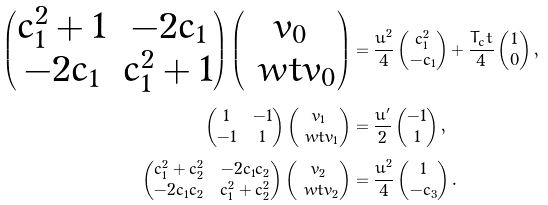<formula> <loc_0><loc_0><loc_500><loc_500>\begin{pmatrix} c _ { 1 } ^ { 2 } + 1 & - 2 c _ { 1 } \\ - 2 c _ { 1 } & c _ { 1 } ^ { 2 } + 1 \end{pmatrix} \begin{pmatrix} v _ { 0 } \\ \ w t { v } _ { 0 } \end{pmatrix} & = \frac { u ^ { 2 } } { 4 } \begin{pmatrix} c _ { 1 } ^ { 2 } \\ - c _ { 1 } \end{pmatrix} + \frac { T _ { c } t } { 4 } \begin{pmatrix} 1 \\ 0 \end{pmatrix} , \\ \begin{pmatrix} 1 & - 1 \\ - 1 & 1 \end{pmatrix} \begin{pmatrix} v _ { 1 } \\ \ w t v _ { 1 } \end{pmatrix} & = \frac { u ^ { \prime } } { 2 } \begin{pmatrix} - 1 \\ 1 \end{pmatrix} , \\ \begin{pmatrix} c _ { 1 } ^ { 2 } + c _ { 2 } ^ { 2 } & - 2 c _ { 1 } c _ { 2 } \\ - 2 c _ { 1 } c _ { 2 } & c _ { 1 } ^ { 2 } + c _ { 2 } ^ { 2 } \end{pmatrix} \begin{pmatrix} v _ { 2 } \\ \ w t v _ { 2 } \end{pmatrix} & = \frac { u ^ { 2 } } { 4 } \begin{pmatrix} 1 \\ - c _ { 3 } \end{pmatrix} .</formula> 